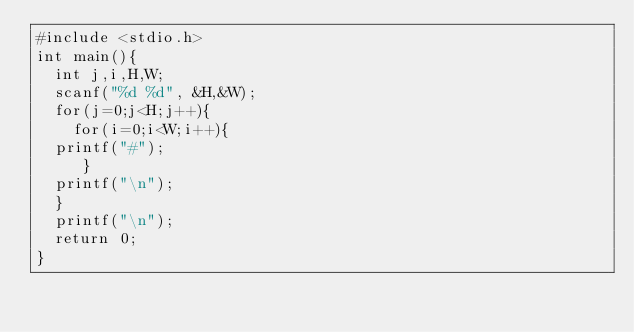Convert code to text. <code><loc_0><loc_0><loc_500><loc_500><_C_>#include <stdio.h>
int main(){
	int j,i,H,W; 
	scanf("%d %d", &H,&W); 
	for(j=0;j<H;j++){
	  for(i=0;i<W;i++){
	printf("#");
	   }
	printf("\n");
	}
	printf("\n");
	return 0;
}
	
</code> 